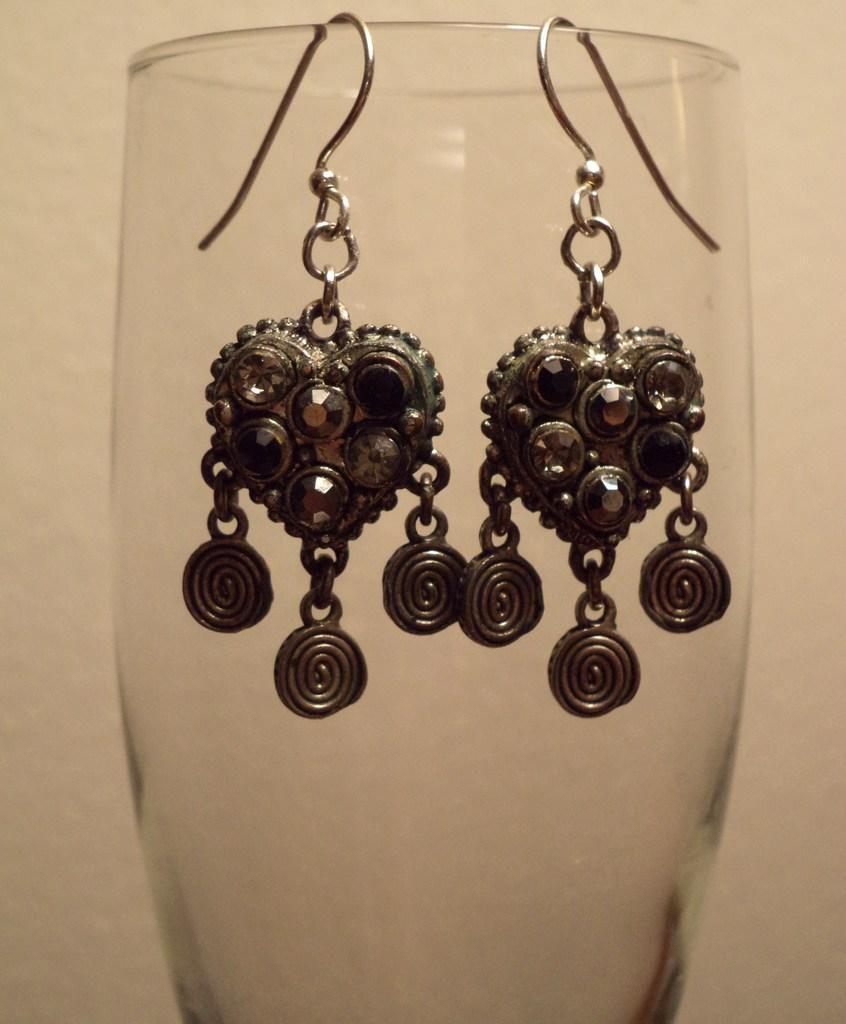Please provide a concise description of this image. In the center of the image we can see a glass. On the glass, we can see a pair of earrings. In the background there is a wall. 